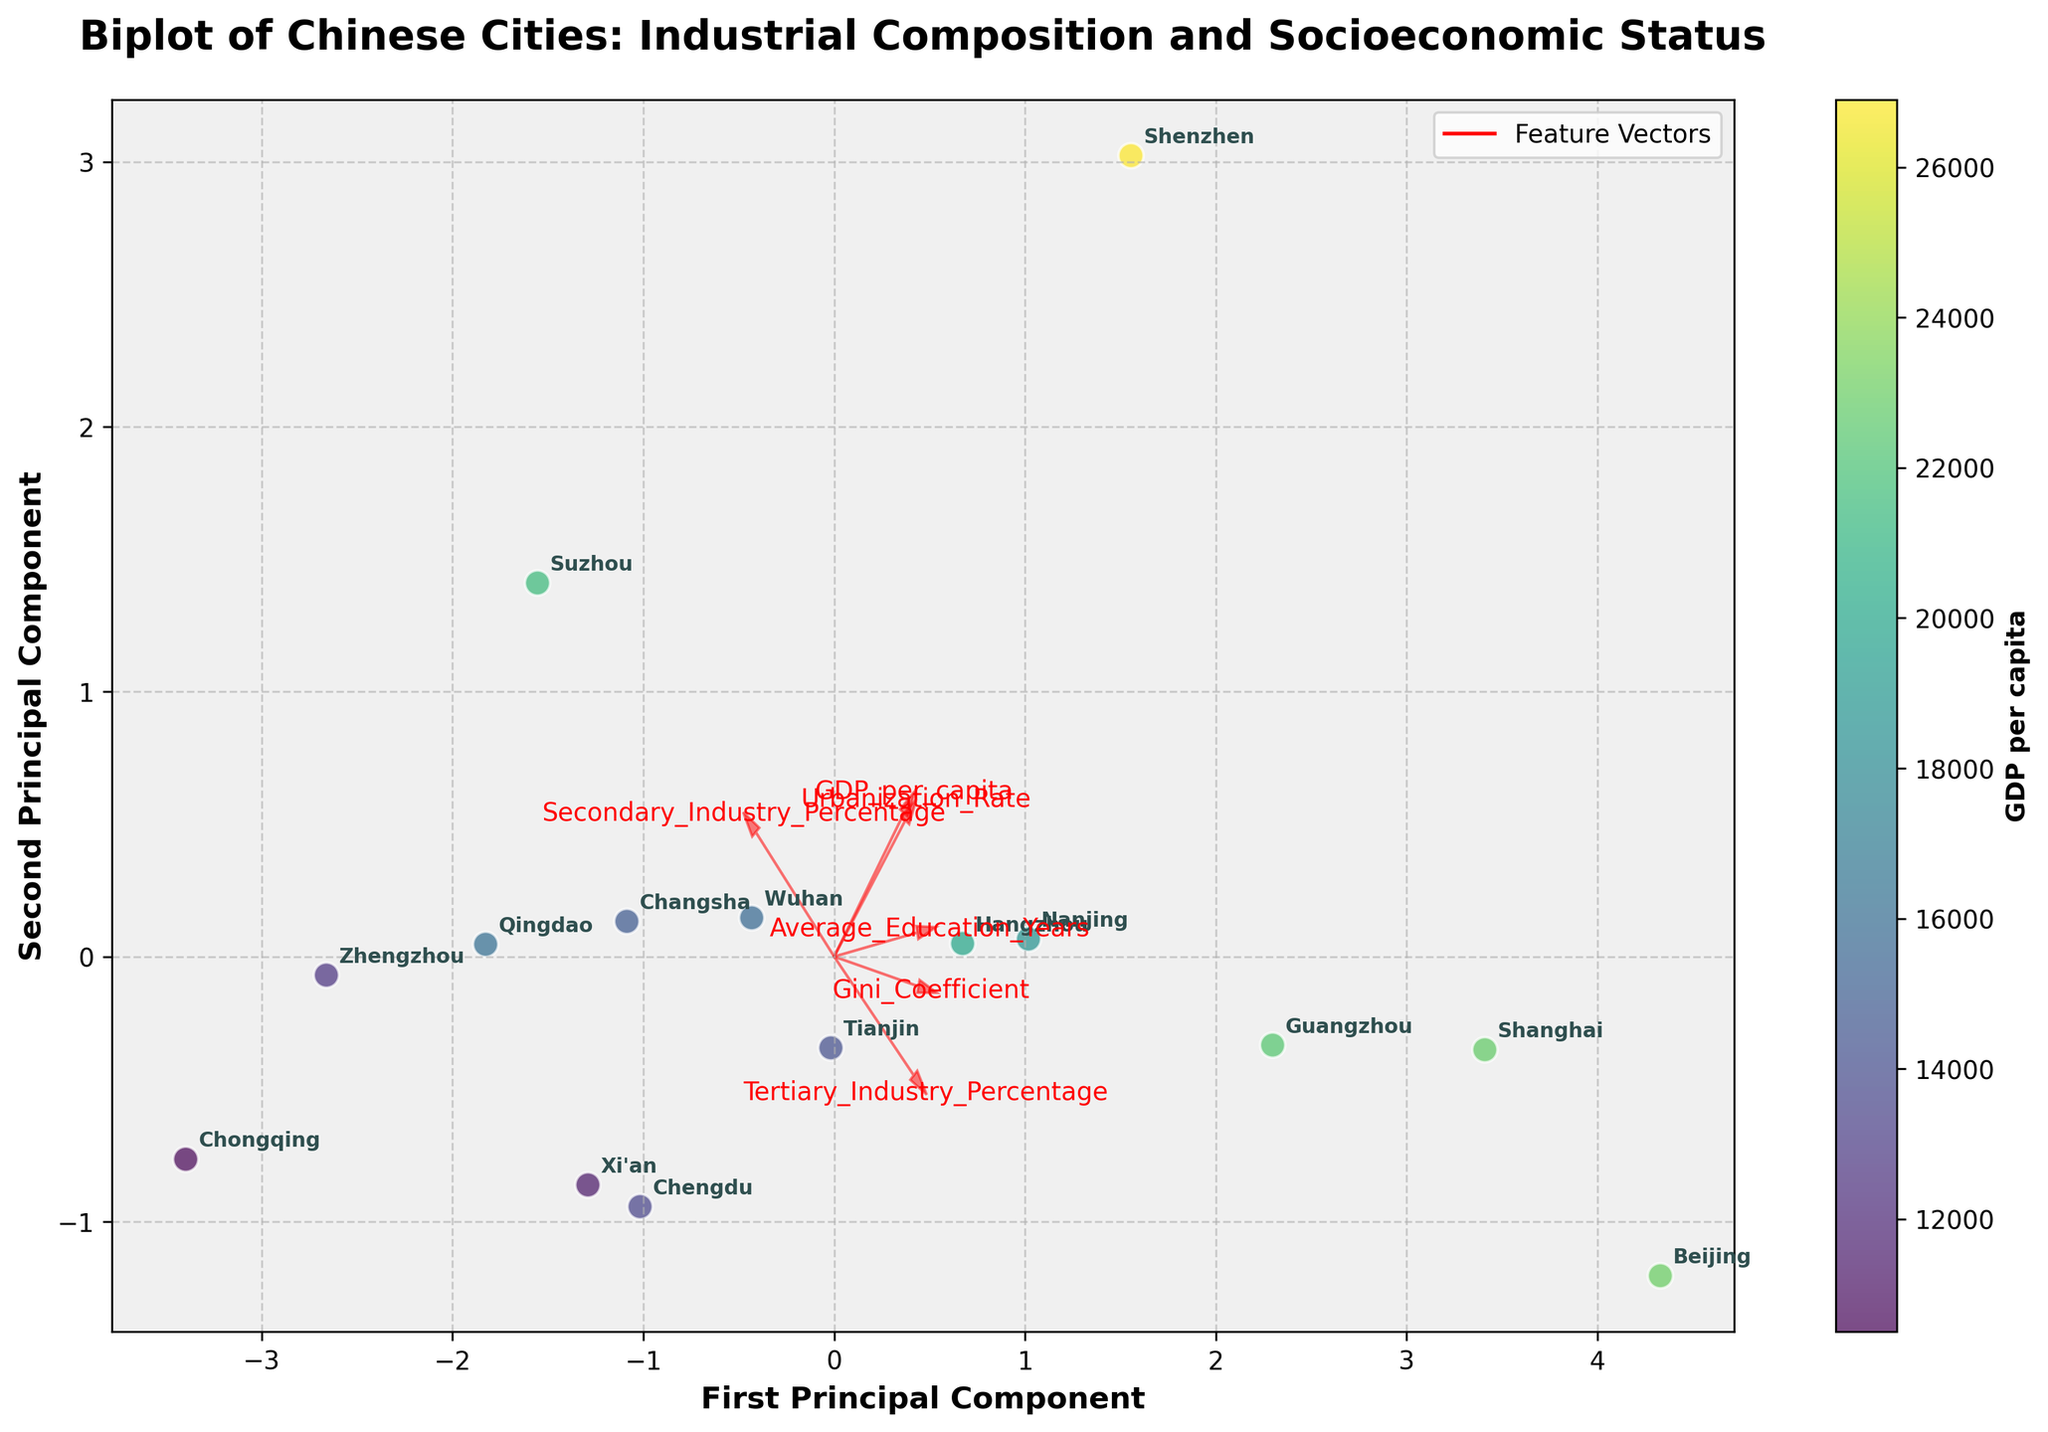What's the title of the figure? The title is displayed on the top of the plot and indicates what the figure is about.
Answer: Biplot of Chinese Cities: Industrial Composition and Socioeconomic Status How are the cities represented in the plot? The plot shows each city as a labeled data point, positioned according to their first two principal components derived from the PCA analysis.
Answer: Labeled data points Which city has the highest GDP per capita, and where is it located on the plot? The color gradient indicates GDP per capita. The city with the highest value will be in the darkest shade on the colorbar. By examining both the color and label, we find Shenzhen has the darkest shade and is likely located at the edge of the plot.
Answer: Shenzhen Which features have the highest influence on the first principal component? To determine this, look at the feature vectors plotted as arrows. The length and direction in alignment with the first principal component (horizontal axis) indicate the influence. The longest arrows in the horizontal direction are 'GDP_per_capita' and 'Secondary_Industry_Percentage'.
Answer: GDP_per_capita and Secondary_Industry_Percentage Which city has the most balanced industrial composition between secondary and tertiary industries? A balanced industrial composition means the percentages of secondary and tertiary industries are close. Observing the plot, we need to look for cities near the middle of the vectors representing these industries. Nanjing is closest to these vectors, indicating a balanced composition.
Answer: Nanjing How does urbanization rate correlate with the second principal component? The direction and magnitude of the Urbanization_Rate vector relative to the second principal component (vertical axis) show the correlation. The arrow for Urbanization_Rate aligns closely with the vertical direction, suggesting a strong positive correlation with the second principal component.
Answer: Strong positive correlation Which city is most associated with a higher Gini Coefficient and where is it positioned on the plot? The Gini Coefficient vector points in a specific direction on the plot. The city positioned further along this vector will correspond to a higher Gini Coefficient. Beijing, positioned in line with the Gini Coefficient vector, has the higher value.
Answer: Beijing 